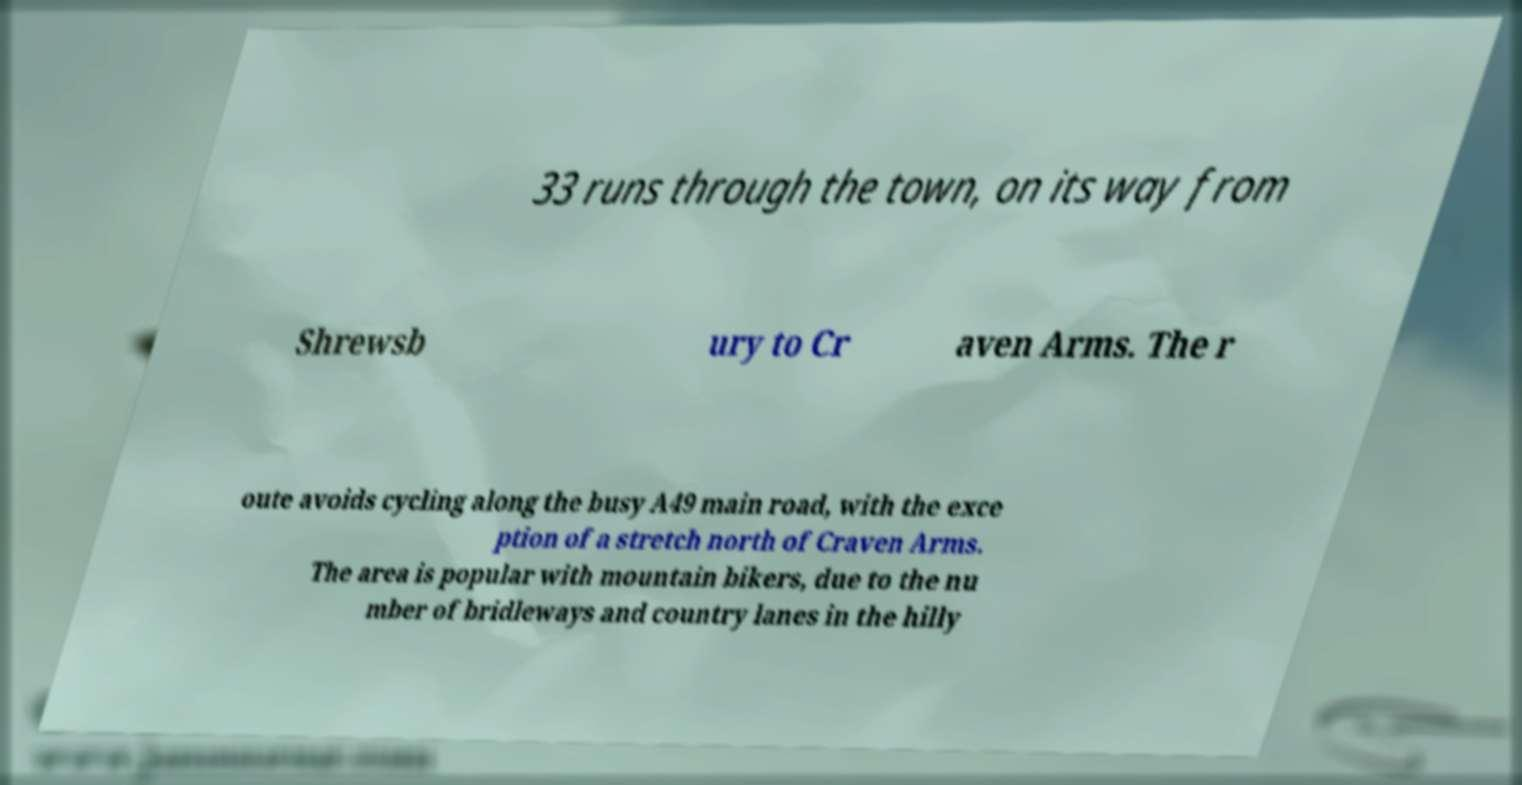Can you accurately transcribe the text from the provided image for me? 33 runs through the town, on its way from Shrewsb ury to Cr aven Arms. The r oute avoids cycling along the busy A49 main road, with the exce ption of a stretch north of Craven Arms. The area is popular with mountain bikers, due to the nu mber of bridleways and country lanes in the hilly 